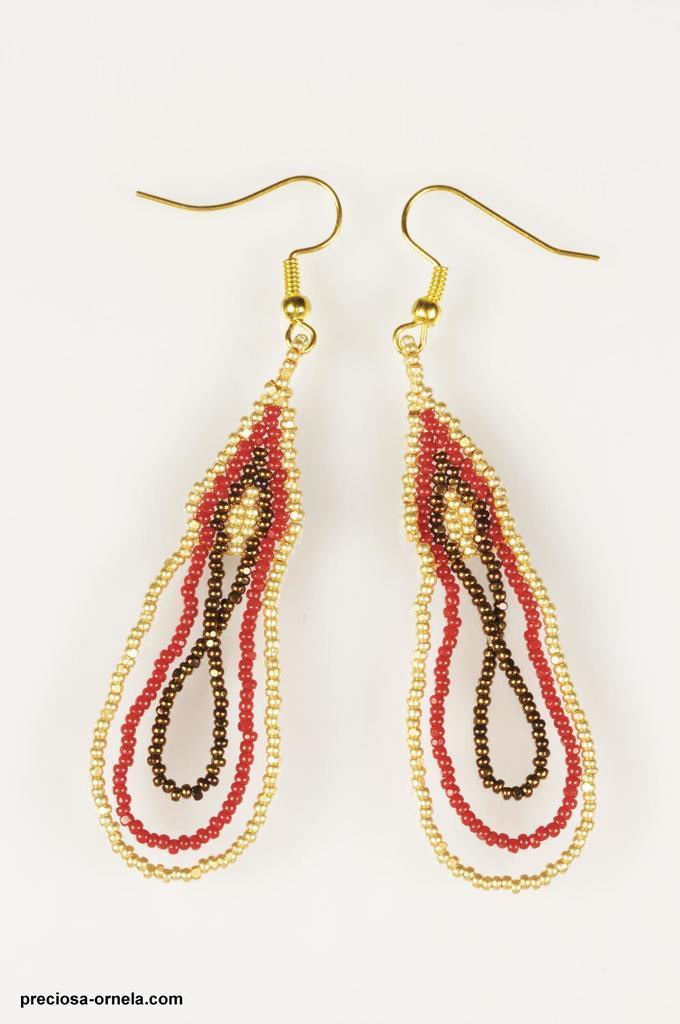How would you summarize this image in a sentence or two? In this image I can see ear rings, they are in gold, brown and red color. 